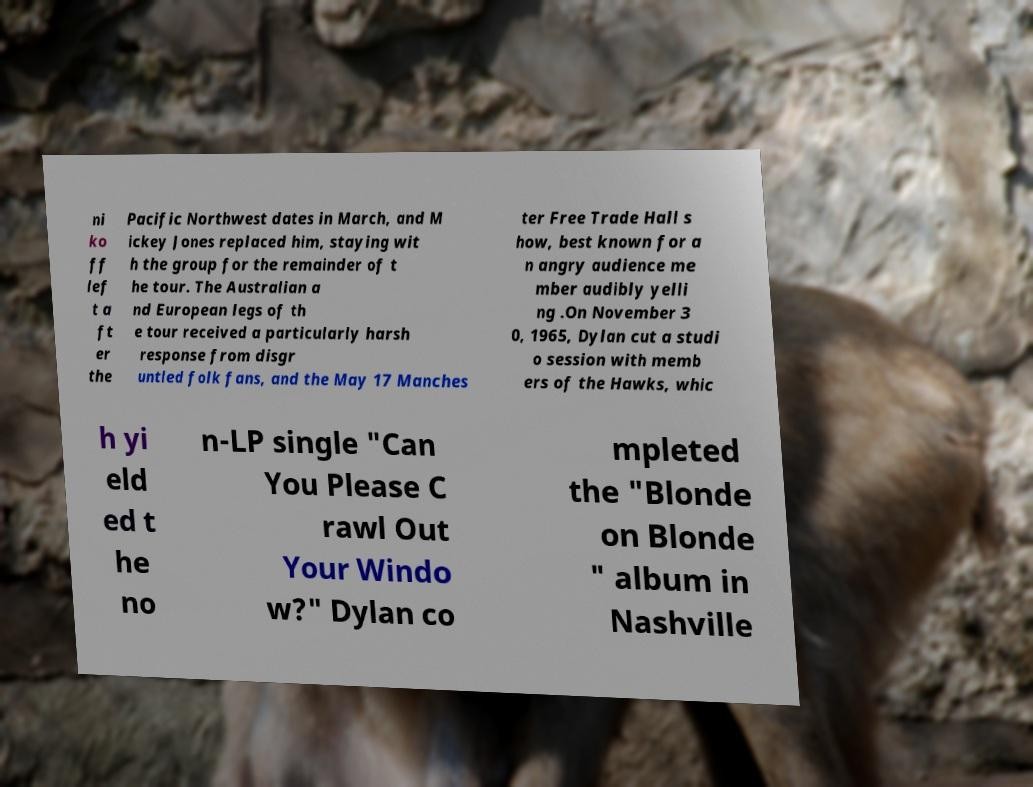What messages or text are displayed in this image? I need them in a readable, typed format. ni ko ff lef t a ft er the Pacific Northwest dates in March, and M ickey Jones replaced him, staying wit h the group for the remainder of t he tour. The Australian a nd European legs of th e tour received a particularly harsh response from disgr untled folk fans, and the May 17 Manches ter Free Trade Hall s how, best known for a n angry audience me mber audibly yelli ng .On November 3 0, 1965, Dylan cut a studi o session with memb ers of the Hawks, whic h yi eld ed t he no n-LP single "Can You Please C rawl Out Your Windo w?" Dylan co mpleted the "Blonde on Blonde " album in Nashville 